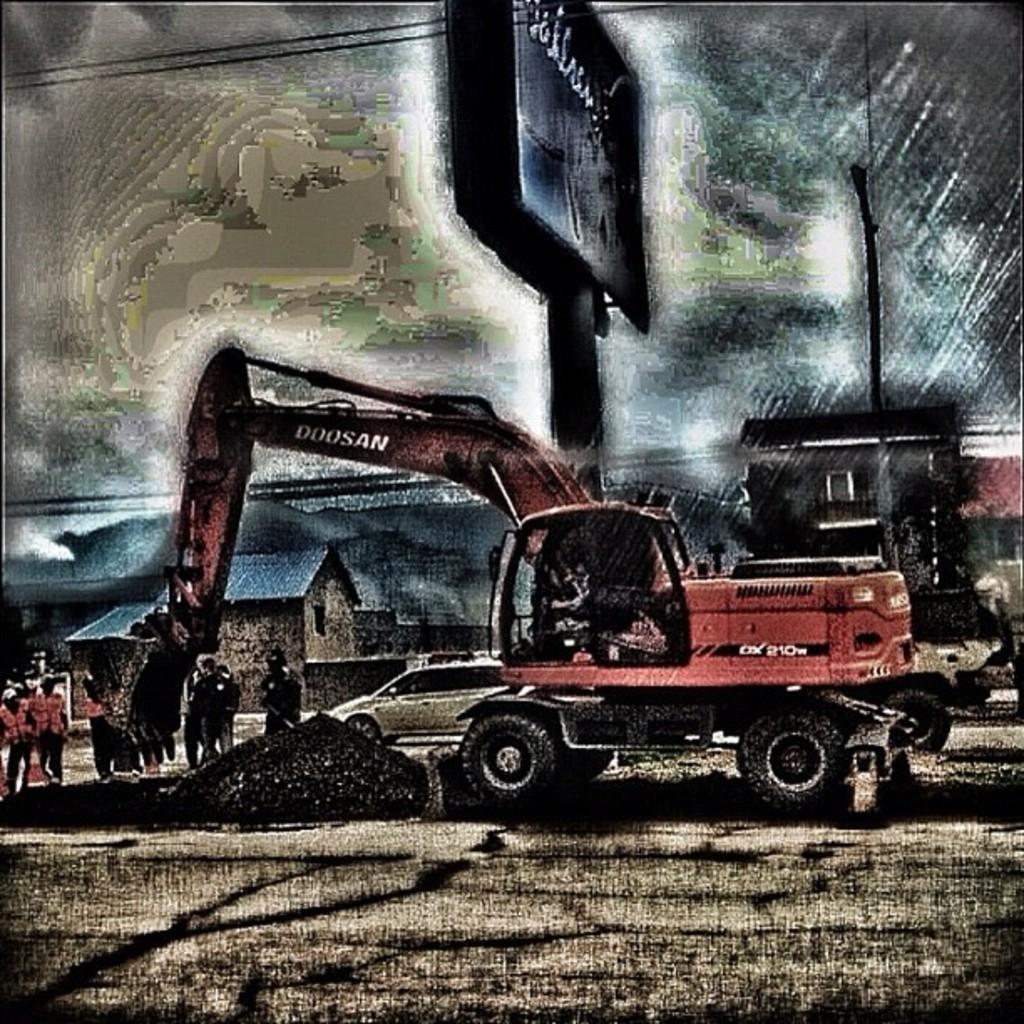What type of construction equipment is present in the image? There is a bulldozer in the image. What else can be seen on the road in the image? There are people standing on the road and vehicles on the road in the image. What type of structures are visible in the image? There are houses visible in the image. What other objects can be seen in the image? There are hoardings and wires in the image. What is visible in the background of the image? The sky is visible in the background of the image. What color is the orange that the bulldozer is peeling in the image? There is no orange present in the image, and the bulldozer is not peeling anything. 